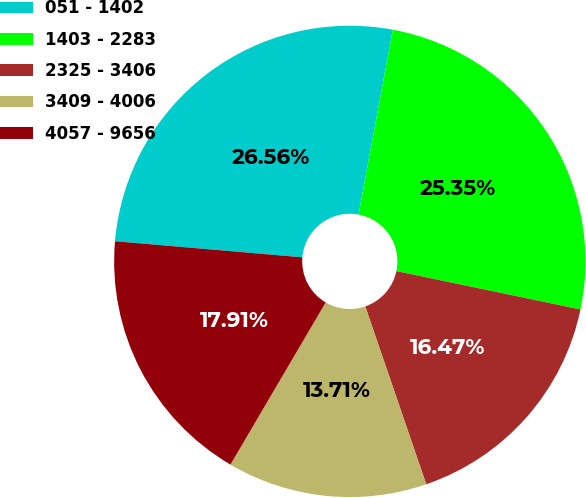<chart> <loc_0><loc_0><loc_500><loc_500><pie_chart><fcel>051 - 1402<fcel>1403 - 2283<fcel>2325 - 3406<fcel>3409 - 4006<fcel>4057 - 9656<nl><fcel>26.56%<fcel>25.35%<fcel>16.47%<fcel>13.71%<fcel>17.91%<nl></chart> 